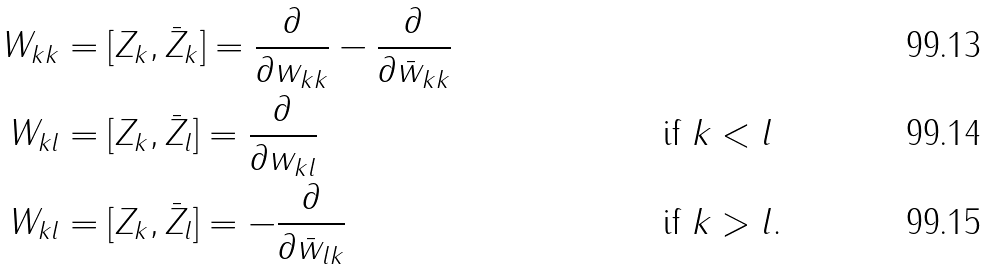Convert formula to latex. <formula><loc_0><loc_0><loc_500><loc_500>W _ { k k } & = [ Z _ { k } , \bar { Z } _ { k } ] = \frac { \partial } { \partial w _ { k k } } - \frac { \partial } { \partial \bar { w } _ { k k } } & \\ W _ { k l } & = [ Z _ { k } , \bar { Z } _ { l } ] = \frac { \partial } { \partial w _ { k l } } & & \text { if } k < l \\ W _ { k l } & = [ Z _ { k } , \bar { Z } _ { l } ] = - \frac { \partial } { \partial \bar { w } _ { l k } } & & \text { if } k > l .</formula> 